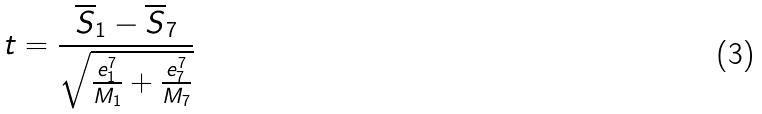<formula> <loc_0><loc_0><loc_500><loc_500>t = \frac { \overline { S } _ { 1 } - \overline { S } _ { 7 } } { \sqrt { \frac { e _ { 1 } ^ { 7 } } { M _ { 1 } } + \frac { e _ { 7 } ^ { 7 } } { M _ { 7 } } } }</formula> 